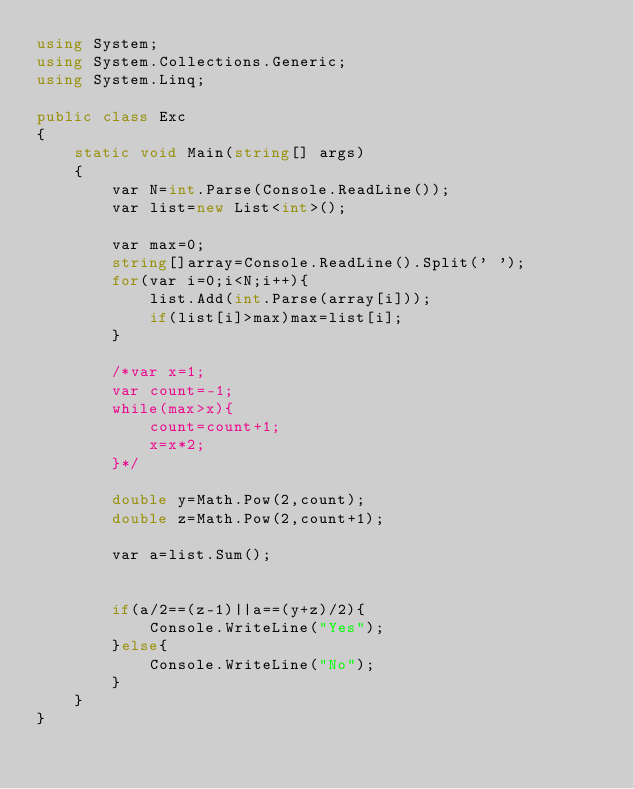Convert code to text. <code><loc_0><loc_0><loc_500><loc_500><_C#_>using System;
using System.Collections.Generic;
using System.Linq;

public class Exc
{
    static void Main(string[] args)
    {
        var N=int.Parse(Console.ReadLine());
        var list=new List<int>();
        
        var max=0;
        string[]array=Console.ReadLine().Split(' ');
        for(var i=0;i<N;i++){
            list.Add(int.Parse(array[i]));
            if(list[i]>max)max=list[i];
        }
        
        /*var x=1;
        var count=-1;
        while(max>x){
            count=count+1;
            x=x*2;
        }*/
        
        double y=Math.Pow(2,count);
        double z=Math.Pow(2,count+1);
        
        var a=list.Sum();
        
        
        if(a/2==(z-1)||a==(y+z)/2){
            Console.WriteLine("Yes");
        }else{
            Console.WriteLine("No");
        }
    }
}</code> 